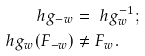<formula> <loc_0><loc_0><loc_500><loc_500>\ h g _ { - w } & = \ h g ^ { - 1 } _ { w } ; \\ \ h g _ { w } ( F _ { - w } ) & \neq F _ { w } .</formula> 